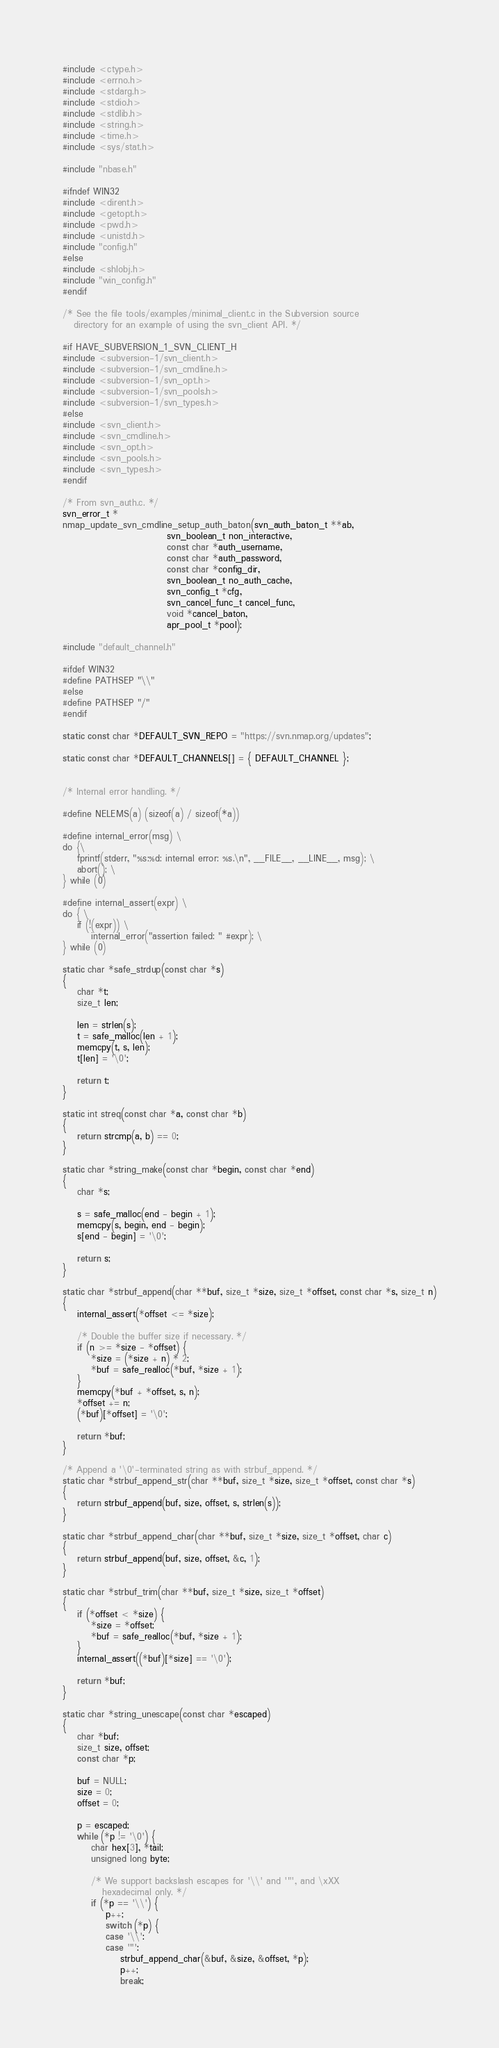Convert code to text. <code><loc_0><loc_0><loc_500><loc_500><_C_>#include <ctype.h>
#include <errno.h>
#include <stdarg.h>
#include <stdio.h>
#include <stdlib.h>
#include <string.h>
#include <time.h>
#include <sys/stat.h>

#include "nbase.h"

#ifndef WIN32
#include <dirent.h>
#include <getopt.h>
#include <pwd.h>
#include <unistd.h>
#include "config.h"
#else
#include <shlobj.h>
#include "win_config.h"
#endif

/* See the file tools/examples/minimal_client.c in the Subversion source
   directory for an example of using the svn_client API. */

#if HAVE_SUBVERSION_1_SVN_CLIENT_H
#include <subversion-1/svn_client.h>
#include <subversion-1/svn_cmdline.h>
#include <subversion-1/svn_opt.h>
#include <subversion-1/svn_pools.h>
#include <subversion-1/svn_types.h>
#else
#include <svn_client.h>
#include <svn_cmdline.h>
#include <svn_opt.h>
#include <svn_pools.h>
#include <svn_types.h>
#endif

/* From svn_auth.c. */
svn_error_t *
nmap_update_svn_cmdline_setup_auth_baton(svn_auth_baton_t **ab,
                             svn_boolean_t non_interactive,
                             const char *auth_username,
                             const char *auth_password,
                             const char *config_dir,
                             svn_boolean_t no_auth_cache,
                             svn_config_t *cfg,
                             svn_cancel_func_t cancel_func,
                             void *cancel_baton,
                             apr_pool_t *pool);

#include "default_channel.h"

#ifdef WIN32
#define PATHSEP "\\"
#else
#define PATHSEP "/"
#endif

static const char *DEFAULT_SVN_REPO = "https://svn.nmap.org/updates";

static const char *DEFAULT_CHANNELS[] = { DEFAULT_CHANNEL };


/* Internal error handling. */

#define NELEMS(a) (sizeof(a) / sizeof(*a))

#define internal_error(msg) \
do {\
	fprintf(stderr, "%s:%d: internal error: %s.\n", __FILE__, __LINE__, msg); \
	abort(); \
} while (0)

#define internal_assert(expr) \
do { \
	if (!(expr)) \
		internal_error("assertion failed: " #expr); \
} while (0)

static char *safe_strdup(const char *s)
{
	char *t;
	size_t len;

	len = strlen(s);
	t = safe_malloc(len + 1);
	memcpy(t, s, len);
	t[len] = '\0';

	return t;
}

static int streq(const char *a, const char *b)
{
	return strcmp(a, b) == 0;
}

static char *string_make(const char *begin, const char *end)
{
	char *s;

	s = safe_malloc(end - begin + 1);
	memcpy(s, begin, end - begin);
	s[end - begin] = '\0';

	return s;
}

static char *strbuf_append(char **buf, size_t *size, size_t *offset, const char *s, size_t n)
{
	internal_assert(*offset <= *size);

	/* Double the buffer size if necessary. */
	if (n >= *size - *offset) {
		*size = (*size + n) * 2;
		*buf = safe_realloc(*buf, *size + 1);
	}
	memcpy(*buf + *offset, s, n);
	*offset += n;
	(*buf)[*offset] = '\0';

	return *buf;
}

/* Append a '\0'-terminated string as with strbuf_append. */
static char *strbuf_append_str(char **buf, size_t *size, size_t *offset, const char *s)
{
	return strbuf_append(buf, size, offset, s, strlen(s));
}

static char *strbuf_append_char(char **buf, size_t *size, size_t *offset, char c)
{
	return strbuf_append(buf, size, offset, &c, 1);
}

static char *strbuf_trim(char **buf, size_t *size, size_t *offset)
{
	if (*offset < *size) {
		*size = *offset;
		*buf = safe_realloc(*buf, *size + 1);
	}
	internal_assert((*buf)[*size] == '\0');

	return *buf;
}

static char *string_unescape(const char *escaped)
{
	char *buf;
	size_t size, offset;
	const char *p;

	buf = NULL;
	size = 0;
	offset = 0;

	p = escaped;
	while (*p != '\0') {
		char hex[3], *tail;
		unsigned long byte;

		/* We support backslash escapes for '\\' and '"', and \xXX
		   hexadecimal only. */
		if (*p == '\\') {
			p++;
			switch (*p) {
			case '\\':
			case '"':
				strbuf_append_char(&buf, &size, &offset, *p);
				p++;
				break;</code> 